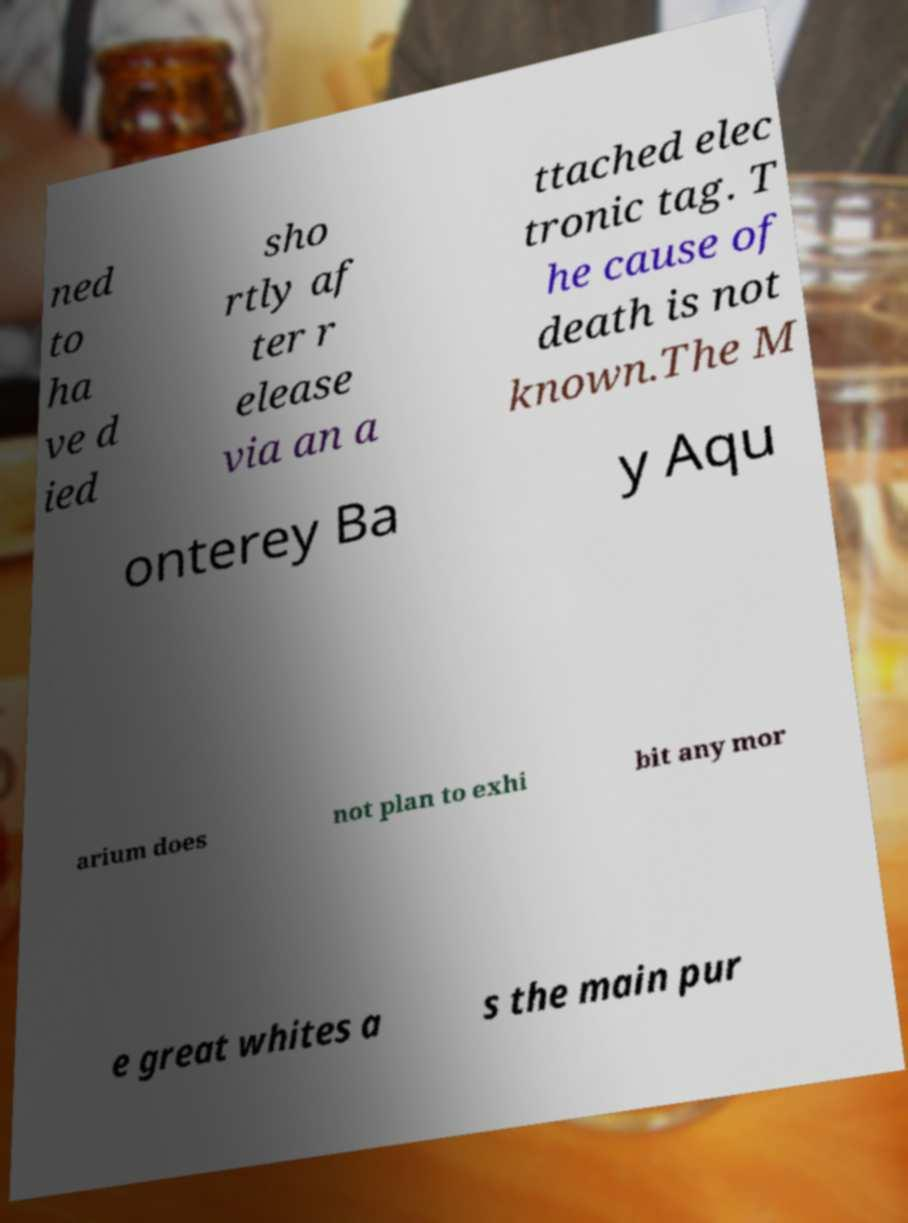For documentation purposes, I need the text within this image transcribed. Could you provide that? ned to ha ve d ied sho rtly af ter r elease via an a ttached elec tronic tag. T he cause of death is not known.The M onterey Ba y Aqu arium does not plan to exhi bit any mor e great whites a s the main pur 